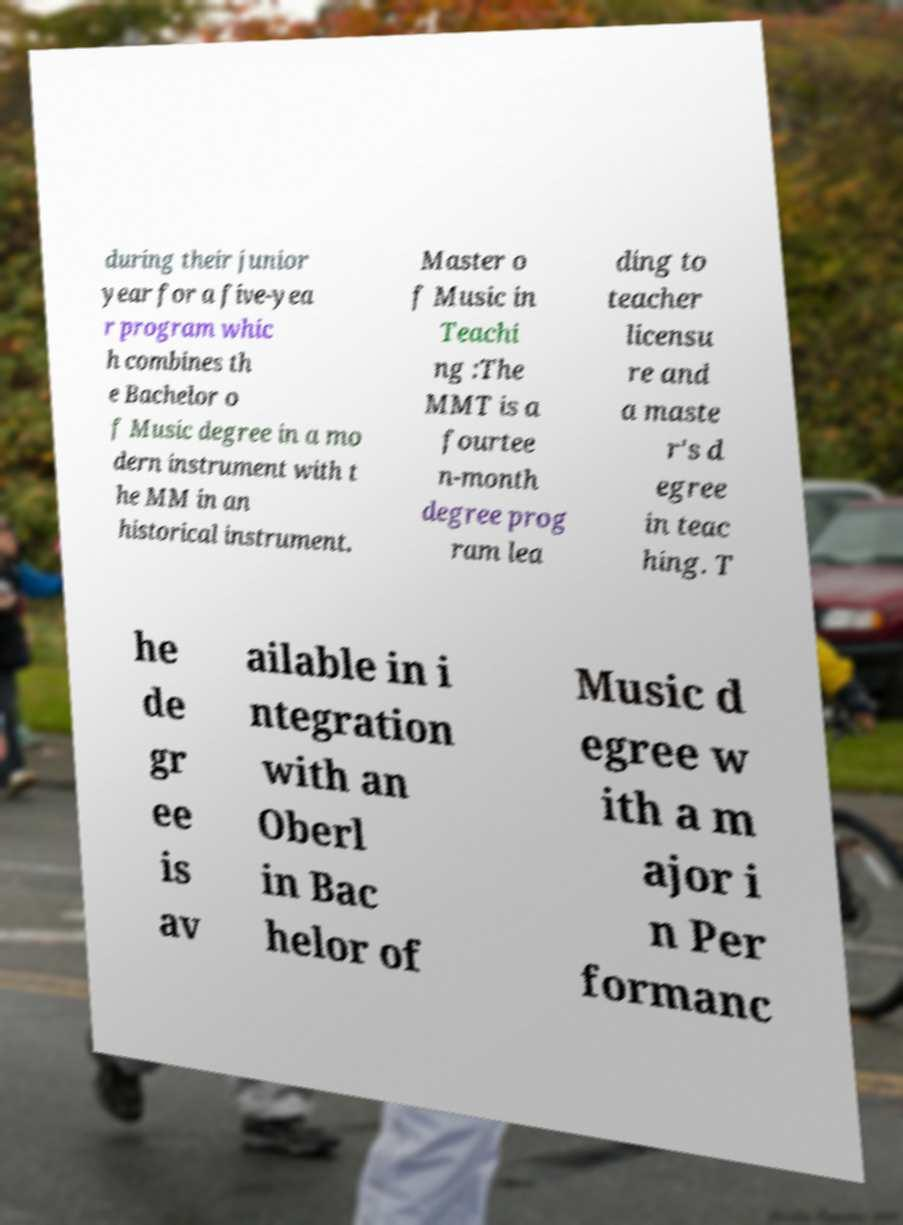There's text embedded in this image that I need extracted. Can you transcribe it verbatim? during their junior year for a five-yea r program whic h combines th e Bachelor o f Music degree in a mo dern instrument with t he MM in an historical instrument. Master o f Music in Teachi ng :The MMT is a fourtee n-month degree prog ram lea ding to teacher licensu re and a maste r's d egree in teac hing. T he de gr ee is av ailable in i ntegration with an Oberl in Bac helor of Music d egree w ith a m ajor i n Per formanc 